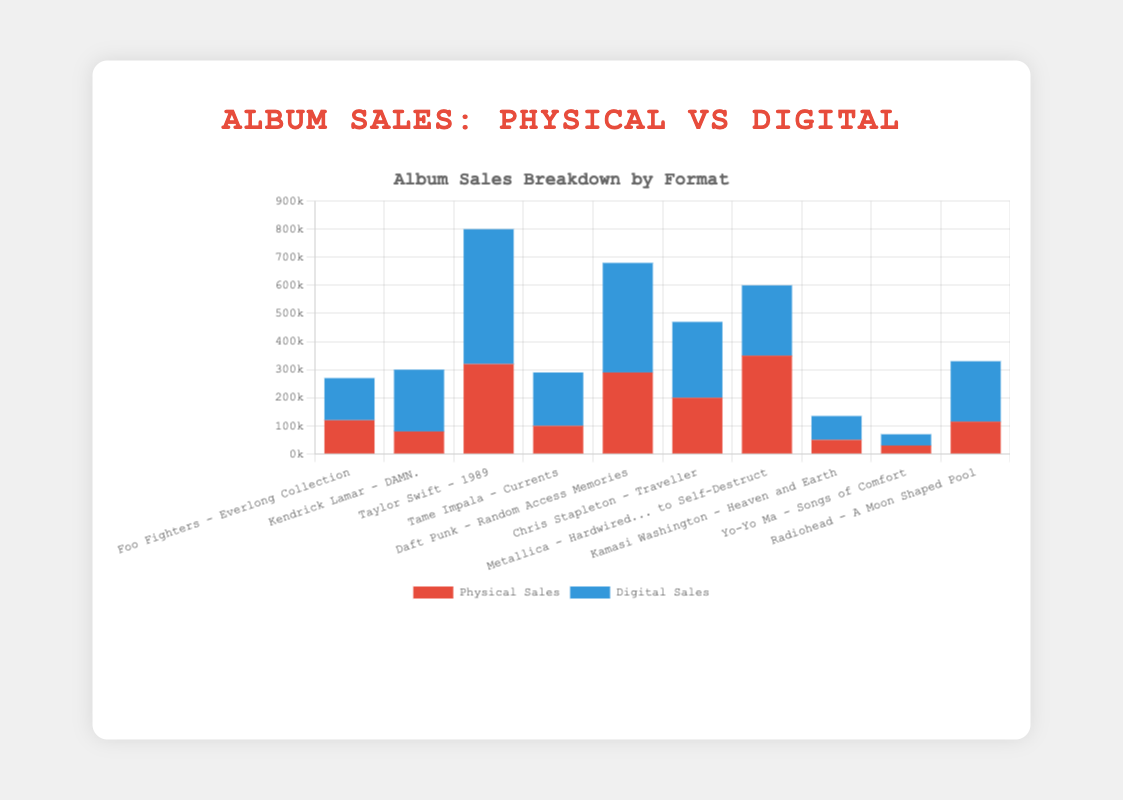What is the total number of physical sales for all albums combined? Add up the physical sales for all albums: 
120000 (Foo Fighters) + 80000 (Kendrick Lamar) + 320000 (Taylor Swift) + 100000 (Tame Impala) + 290000 (Daft Punk) + 200000 (Chris Stapleton) + 350000 (Metallica) + 50000 (Kamasi Washington) + 30000 (Yo-Yo Ma) + 115000 (Radiohead) = 1,565,000
Answer: 1,565,000 Which album has the highest digital sales? Compare the digital sales values for each album:
150000 (Foo Fighters), 220000 (Kendrick Lamar), 480000 (Taylor Swift), 190000 (Tame Impala), 390000 (Daft Punk), 270000 (Chris Stapleton), 250000 (Metallica), 85000 (Kamasi Washington), 40000 (Yo-Yo Ma), 215000 (Radiohead).
Taylor Swift’s album "1989" has the highest number: 480000
Answer: Taylor Swift - 1989 Which genre has the lowest sales in both formats combined? Combine physical and digital sales for each genre:
170000 (Rock - Foo Fighters), 300000 (Hip-Hop - Kendrick Lamar), 800000 (Pop - Taylor Swift), 290000 (Indie - Tame Impala), 680000 (Electronic - Daft Punk), 470000 (Country - Chris Stapleton), 600000 (Metal - Metallica), 135000 (Jazz - Kamasi Washington), 70000 (Classical - Yo-Yo Ma), 330000 (Alternative - Radiohead).
Classical (Yo-Yo Ma) has the lowest sales with 70000
Answer: Classical How much more digital sales does Daft Punk's album have compared to its physical sales? Subtract physical sales from digital sales for Daft Punk:
390000 - 290000 = 100000
Answer: 100000 What is the average number of digital sales per album? Sum the digital sales and divide by the number of albums:
(150000 + 220000 + 480000 + 190000 + 390000 + 270000 + 250000 + 85000 + 40000 + 215000) / 10 = 2,290,000 / 10 = 229000
Answer: 229000 Which artist has equal or almost similar combined physical and digital sales? Check the combined physical and digital sales for each artist to see if they are nearly equal:
Foo Fighters: 270000, Kendrick Lamar: 300000, Taylor Swift: 800000, Tame Impala: 290000, Daft Punk: 680000, Chris Stapleton: 470000, Metallica: 600000, Kamasi Washington: 135000, Yo-Yo Ma: 70000, Radiohead: 330000.
Kamasi Washington has close values, with physical sales of 50000 and digital sales of 85000: Total 135000
Answer: Kamasi Washington What is the difference in total (physical + digital) sales for Metallica and Radiohead? Calculate the combined sales for both and then find the difference:
Metallica: 350000 (physical) + 250000 (digital) = 600000, Radiohead: 115000 (physical) + 215000 (digital) = 330000,
Difference = 600000 - 330000 = 270000
Answer: 270000 